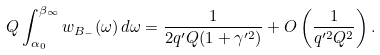<formula> <loc_0><loc_0><loc_500><loc_500>Q \int _ { \alpha _ { 0 } } ^ { \beta _ { \infty } } w _ { B _ { - } } ( \omega ) \, d \omega = \frac { 1 } { 2 q ^ { \prime } Q ( 1 + \gamma ^ { \prime 2 } ) } + O \left ( \frac { 1 } { q ^ { \prime 2 } Q ^ { 2 } } \right ) .</formula> 